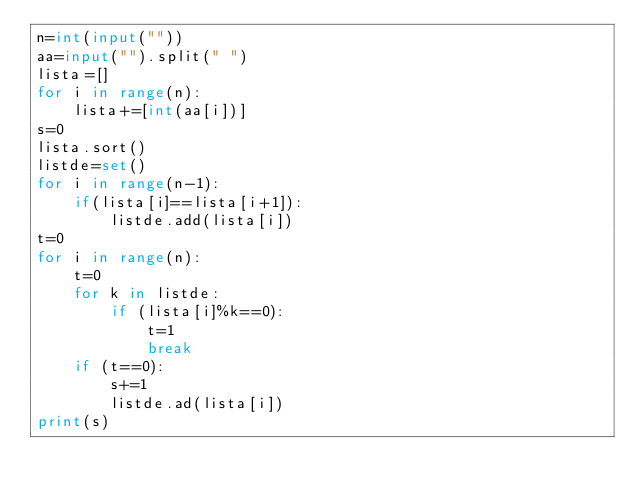<code> <loc_0><loc_0><loc_500><loc_500><_Python_>n=int(input(""))
aa=input("").split(" ")
lista=[]
for i in range(n):
    lista+=[int(aa[i])]
s=0
lista.sort()
listde=set()
for i in range(n-1):
    if(lista[i]==lista[i+1]):
        listde.add(lista[i])
t=0
for i in range(n):
    t=0
    for k in listde:
        if (lista[i]%k==0):
            t=1
            break
    if (t==0):
        s+=1
        listde.ad(lista[i])
print(s)
    
        
</code> 